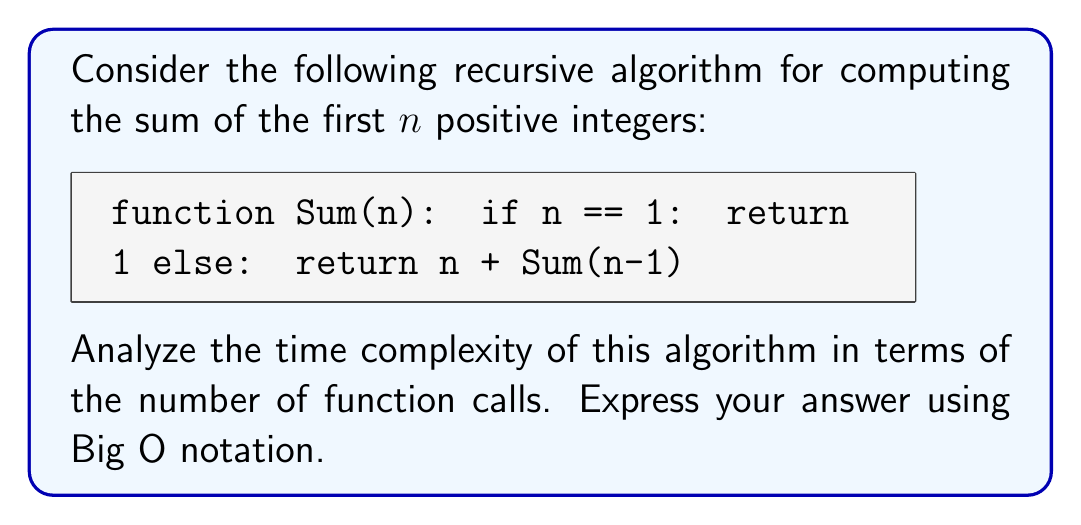Solve this math problem. To analyze the time complexity of this recursive algorithm, we need to consider the number of function calls made during its execution. Let's break it down step by step:

1. Base case: When $n = 1$, the function returns immediately without making any recursive calls.

2. Recursive case: For $n > 1$, the function makes one recursive call to Sum(n-1).

3. Let's trace the function calls for a general input $n$:
   
   $Sum(n)$ calls $Sum(n-1)$
   $Sum(n-1)$ calls $Sum(n-2)$
   $Sum(n-2)$ calls $Sum(n-3)$
   ...
   $Sum(2)$ calls $Sum(1)$
   $Sum(1)$ returns without further calls

4. We can see that the function makes exactly $n$ calls before reaching the base case:
   
   Number of calls = $n$

5. Each function call performs a constant amount of work (addition and comparison), so the time complexity is directly proportional to the number of function calls.

6. Therefore, the time complexity of this algorithm is $O(n)$, where $n$ is the input to the function.

This linear time complexity arises because the algorithm makes one recursive call for each number from $n$ down to 1, resulting in a total of $n$ function calls.
Answer: The time complexity of the given recursive algorithm is $O(n)$. 